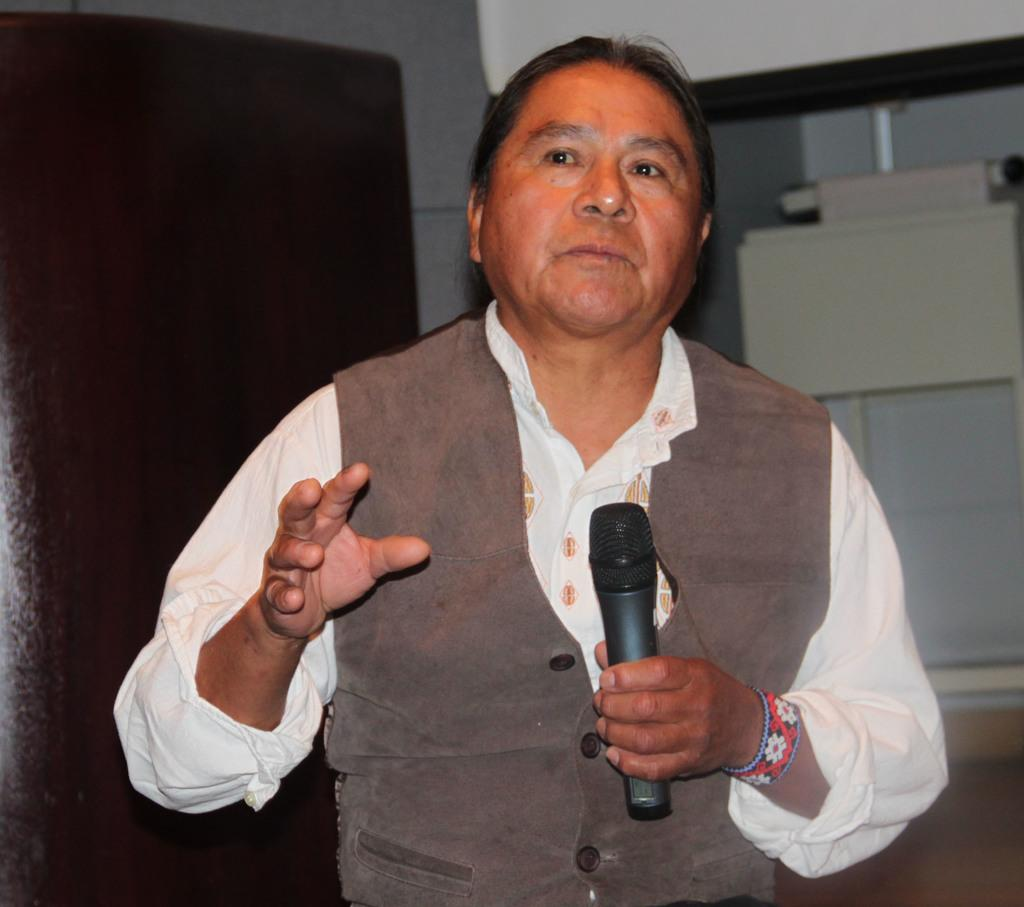Who is present in the image? There is a man in the image. What is the man wearing? The man is wearing a jacket. What is the man holding in his hand? The man is holding a microphone in his hand. What can be seen in the background of the image? There is a door, a wall, and a window in the background of the image. What type of creature is rubbing against the man's leg in the image? There is no creature present in the image, and therefore no such interaction can be observed. 